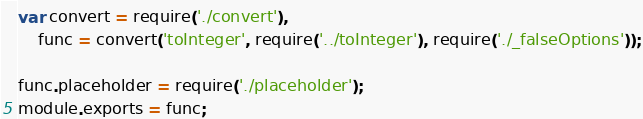Convert code to text. <code><loc_0><loc_0><loc_500><loc_500><_JavaScript_>var convert = require('./convert'),
    func = convert('toInteger', require('../toInteger'), require('./_falseOptions'));

func.placeholder = require('./placeholder');
module.exports = func;</code> 